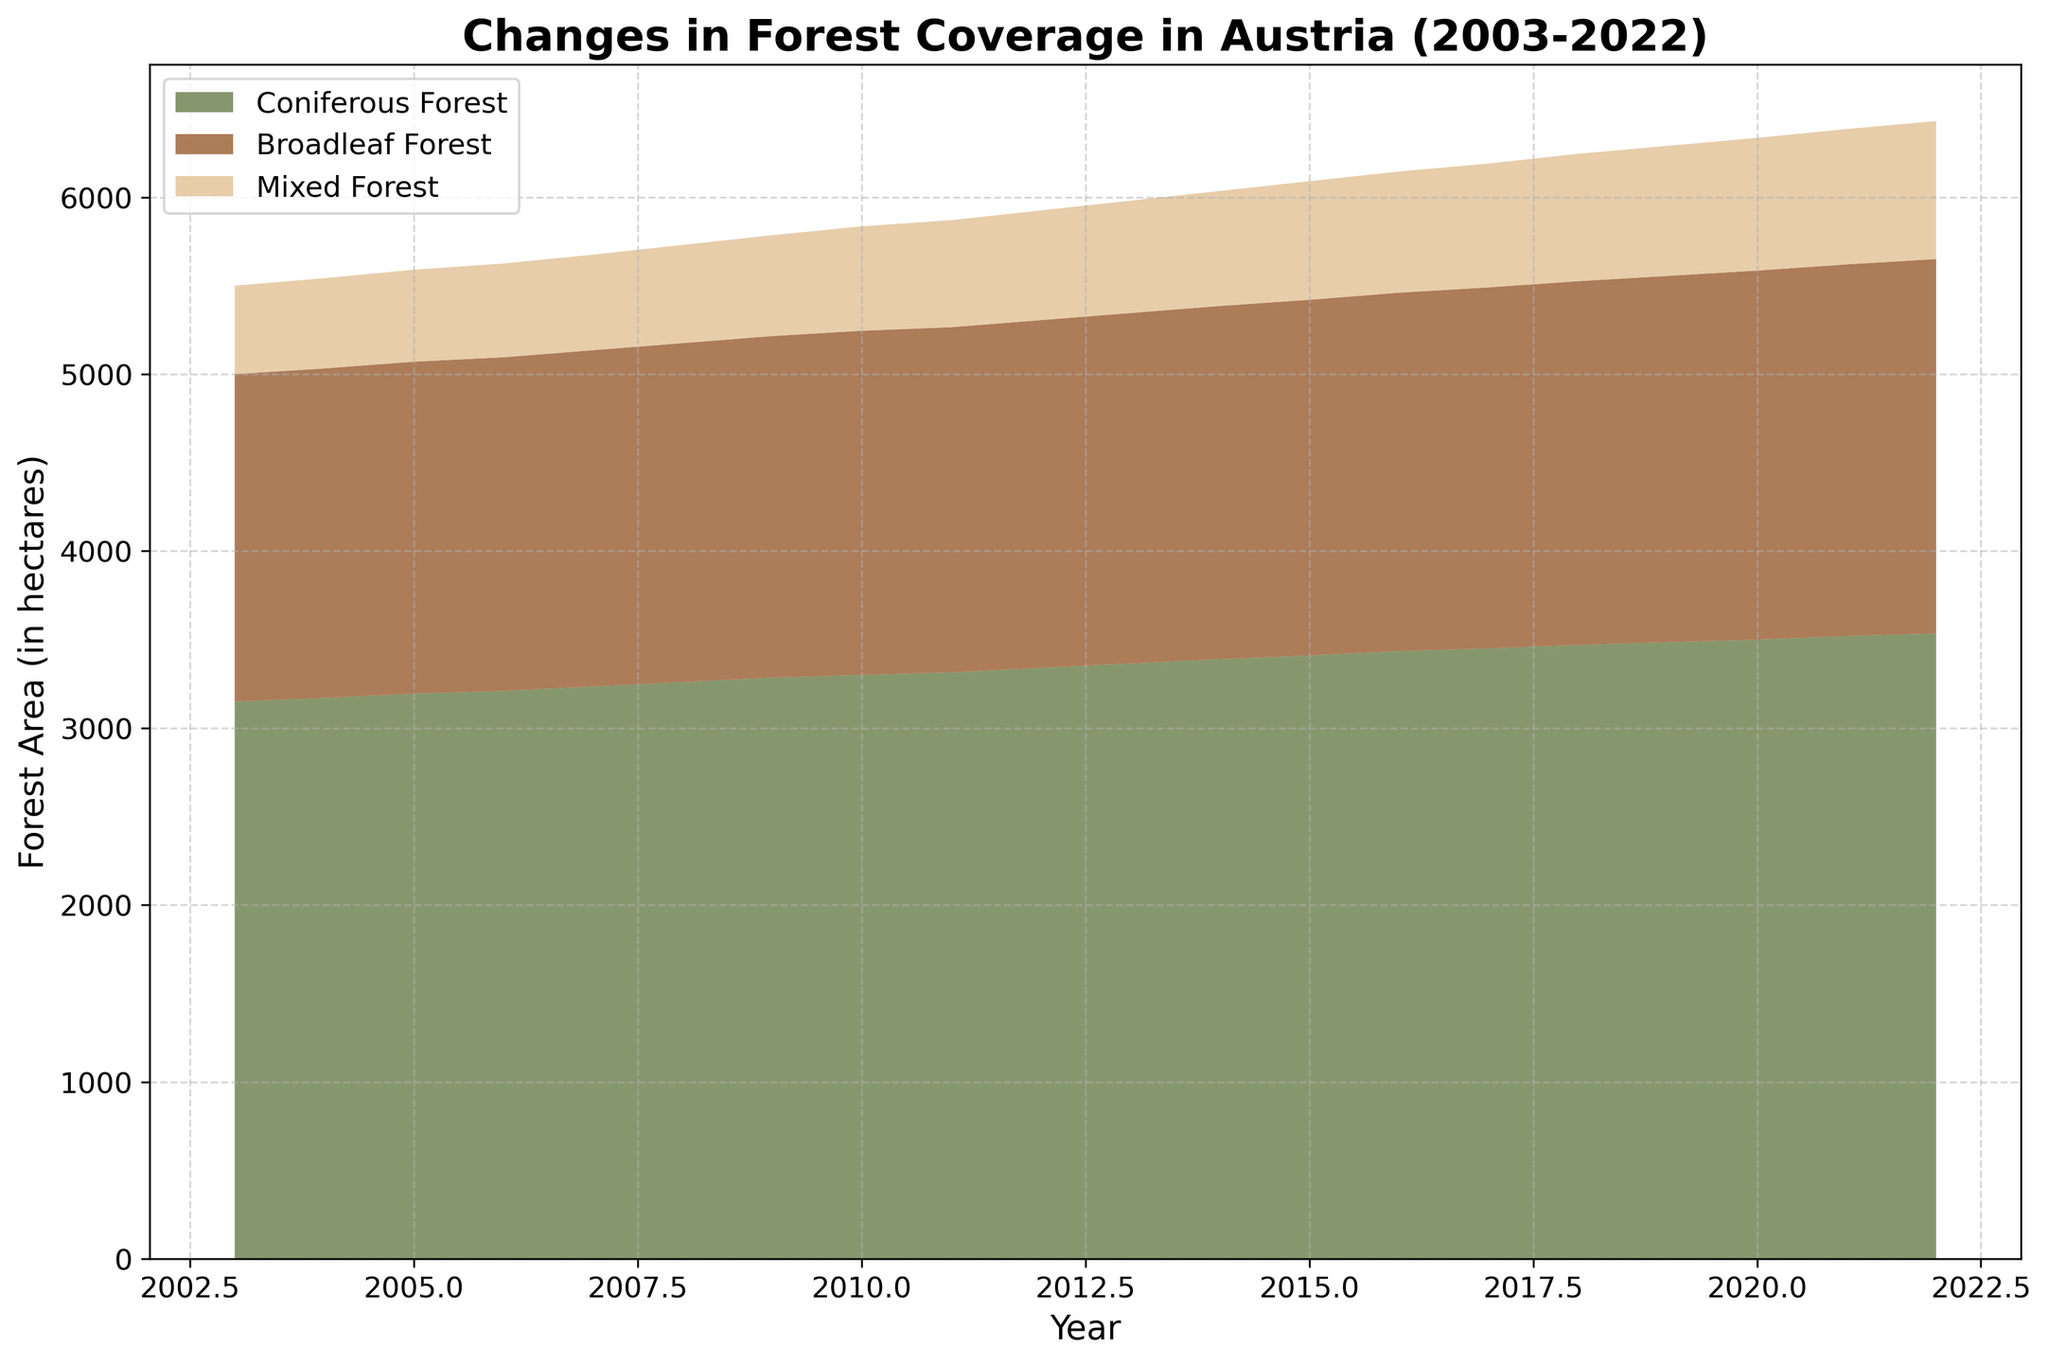How has the total forest area in Austria changed from 2003 to 2022? To determine the total forest area in Austria for each year, we sum the areas of Coniferous Forest, Broadleaf Forest, and Mixed Forest. The figure shows an overall upward trend from 2003 to 2022.
Answer: Increased Which type of forest had the greatest increase in area over the 20-year period? By visually assessing the increasing heights of the different forest types, Coniferous Forest shows the greatest increase in area from 2003 to 2022.
Answer: Coniferous Forest In what year did the Mixed Forest cross the 600 hectares mark? Observing the section of the area chart corresponding to Mixed Forest, it crosses the 600 hectares mark between 2010 and 2011.
Answer: 2011 How does the area of Broadleaf Forest in 2020 compare to that in 2010? Look at the specific sections corresponding to Broadleaf Forest for the years 2010 and 2020. In 2010 the area is 1945 hectares, and in 2020 it is 2085 hectares.
Answer: Increased What's the total area of forest in 2015, and what proportion of it was made up of Mixed Forest? Sum the areas of all forest types in 2015: 3410 (Coniferous) + 2010 (Broadleaf) + 670 (Mixed) = 6090 hectares. The proportion made up by Mixed Forest is 670/6090.
Answer: 670/6090 Compare the growth rates of Coniferous and Broadleaf Forests. Which had a higher average annual increase? To calculate growth rates, find the difference over 20 years and divide by 20. For Coniferous: (3535-3150)/20 = 19.25 hectares per year. For Broadleaf: (2115-1850)/20 = 13.25 hectares per year.
Answer: Coniferous Forest What was the forest coverage in 2008, and how does it compare to the coverage in 2018? Find the total forest area in 2008 by summing the individual forest areas: 3260 (Coniferous) + 1915 (Broadleaf) + 555 (Mixed) = 5730 hectares. For 2018, total is 3470 + 2055 + 720 = 6245 hectares.
Answer: Increased Identify the forest type that consistently showed the smallest area throughout the 20-year period. Visually assess the smallest section in height on the area chart for each year, which corresponds to Mixed Forest.
Answer: Mixed Forest What is the difference in the Mixed Forest area between the years 2010 and 2022? Subtract the Mixed Forest area in 2010 from the area in 2022: 780 (2022) - 590 (2010) = 190 hectares.
Answer: 190 hectares How does the forest coverage in 2003 compare with that in 2022 for Broadleaf Forest? The initial area for Broadleaf Forest in 2003 was 1850 hectares, increasing to 2115 hectares by 2022.
Answer: Increased 